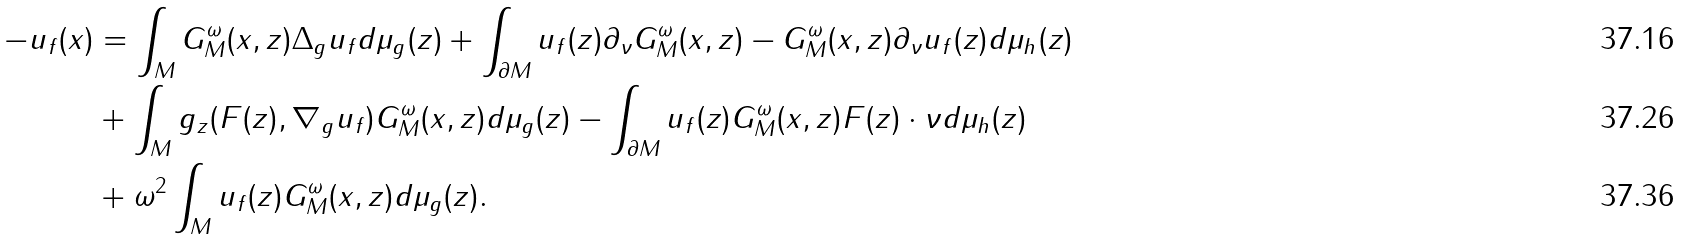<formula> <loc_0><loc_0><loc_500><loc_500>- u _ { f } ( x ) & = \int _ { M } G ^ { \omega } _ { M } ( x , z ) \Delta _ { g } u _ { f } d \mu _ { g } ( z ) + \int _ { \partial M } u _ { f } ( z ) \partial _ { \nu } G ^ { \omega } _ { M } ( x , z ) - G ^ { \omega } _ { M } ( x , z ) \partial _ { \nu } u _ { f } ( z ) d \mu _ { h } ( z ) \\ & + \int _ { M } g _ { z } ( F ( z ) , \nabla _ { g } u _ { f } ) G ^ { \omega } _ { M } ( x , z ) d \mu _ { g } ( z ) - \int _ { \partial M } u _ { f } ( z ) G ^ { \omega } _ { M } ( x , z ) F ( z ) \cdot \nu d \mu _ { h } ( z ) \\ & + \omega ^ { 2 } \int _ { M } u _ { f } ( z ) G ^ { \omega } _ { M } ( x , z ) d \mu _ { g } ( z ) .</formula> 